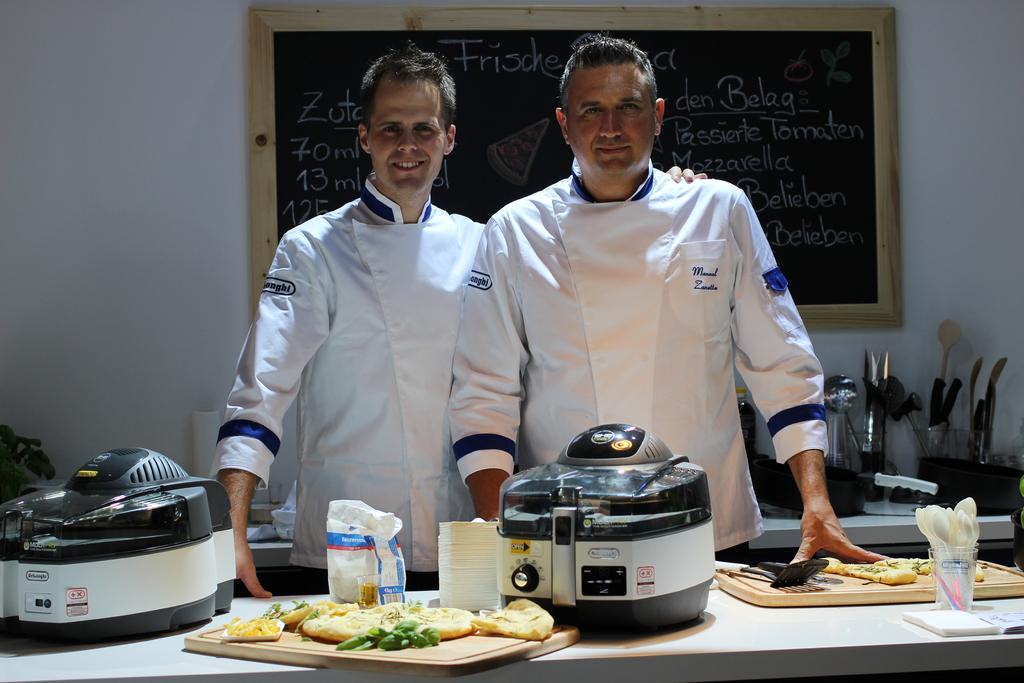How many people are present in the image? There are two people in the image. What can be seen on a table in the image? There are objects on a table in the image. What is written on the blackboard in the background of the image? There is text written on a blackboard in the background of the image. How many books can be seen in the pocket of one of the people in the image? There are no books visible in the image, and no one is shown with a pocket. 